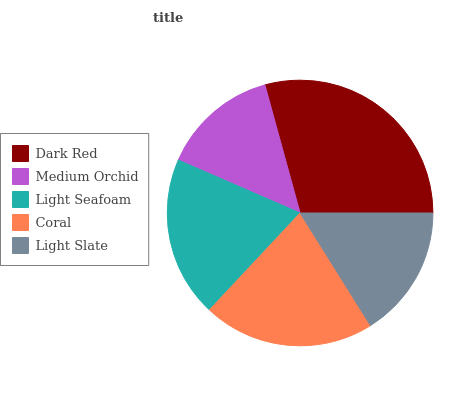Is Medium Orchid the minimum?
Answer yes or no. Yes. Is Dark Red the maximum?
Answer yes or no. Yes. Is Light Seafoam the minimum?
Answer yes or no. No. Is Light Seafoam the maximum?
Answer yes or no. No. Is Light Seafoam greater than Medium Orchid?
Answer yes or no. Yes. Is Medium Orchid less than Light Seafoam?
Answer yes or no. Yes. Is Medium Orchid greater than Light Seafoam?
Answer yes or no. No. Is Light Seafoam less than Medium Orchid?
Answer yes or no. No. Is Light Seafoam the high median?
Answer yes or no. Yes. Is Light Seafoam the low median?
Answer yes or no. Yes. Is Coral the high median?
Answer yes or no. No. Is Coral the low median?
Answer yes or no. No. 